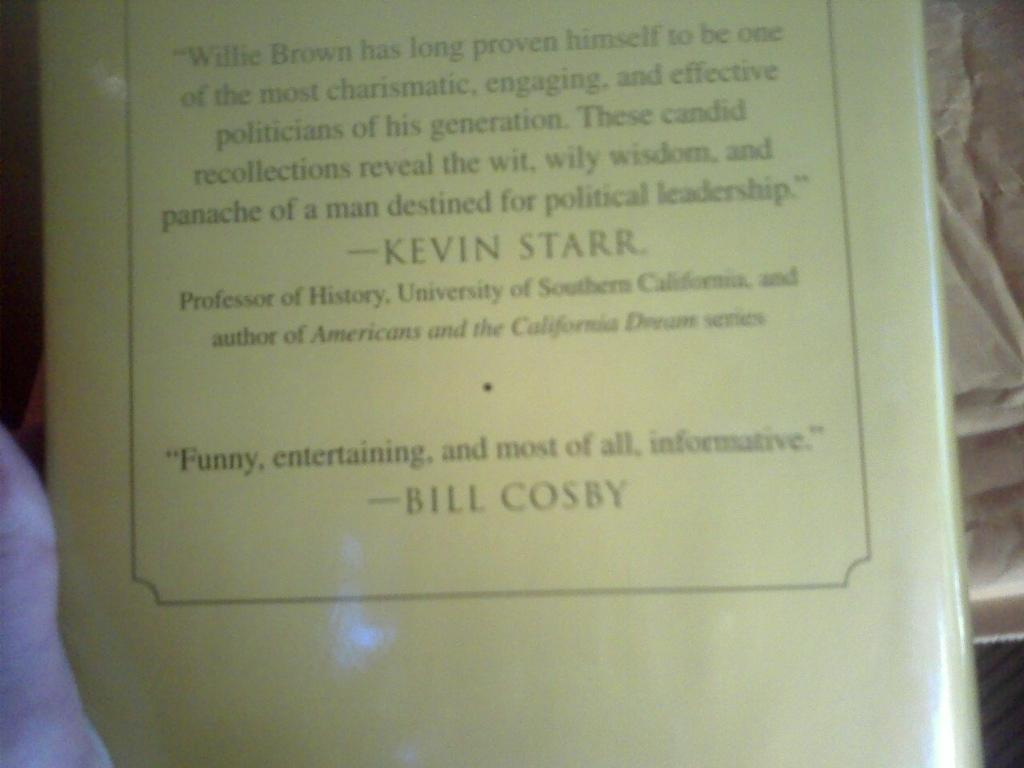<image>
Write a terse but informative summary of the picture. A picture of the back of a book with a quote from BILL COSBY. 